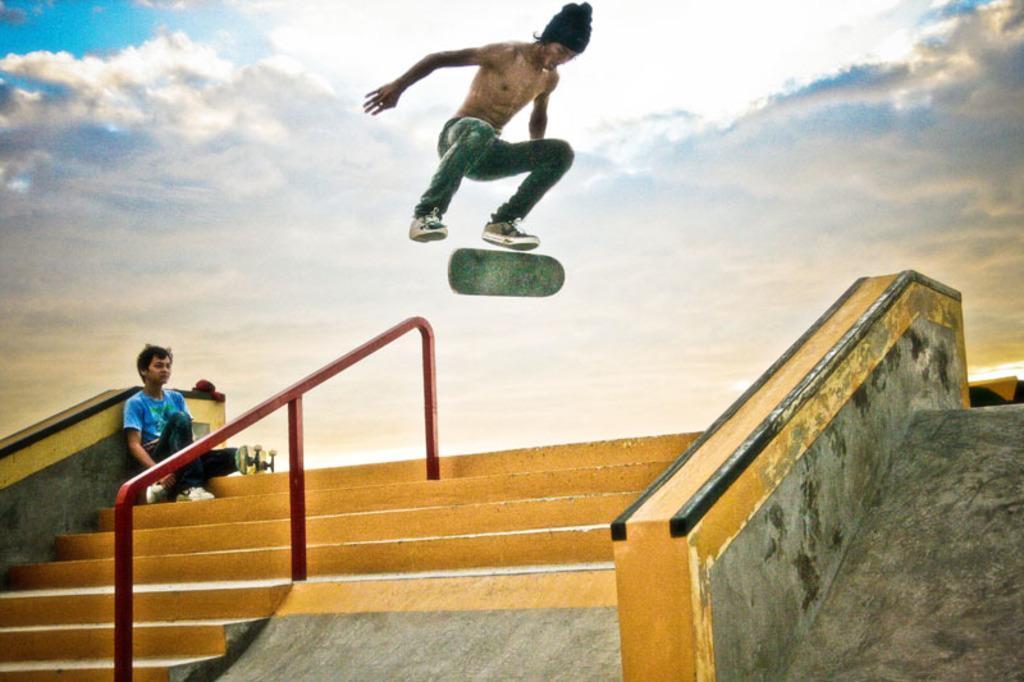Can you describe this image briefly? This is an edited picture. At the bottom there are staircase, railing, skateboard and a person sitting. In the center of the picture there is a person skating. Sky is partially cloudy. 